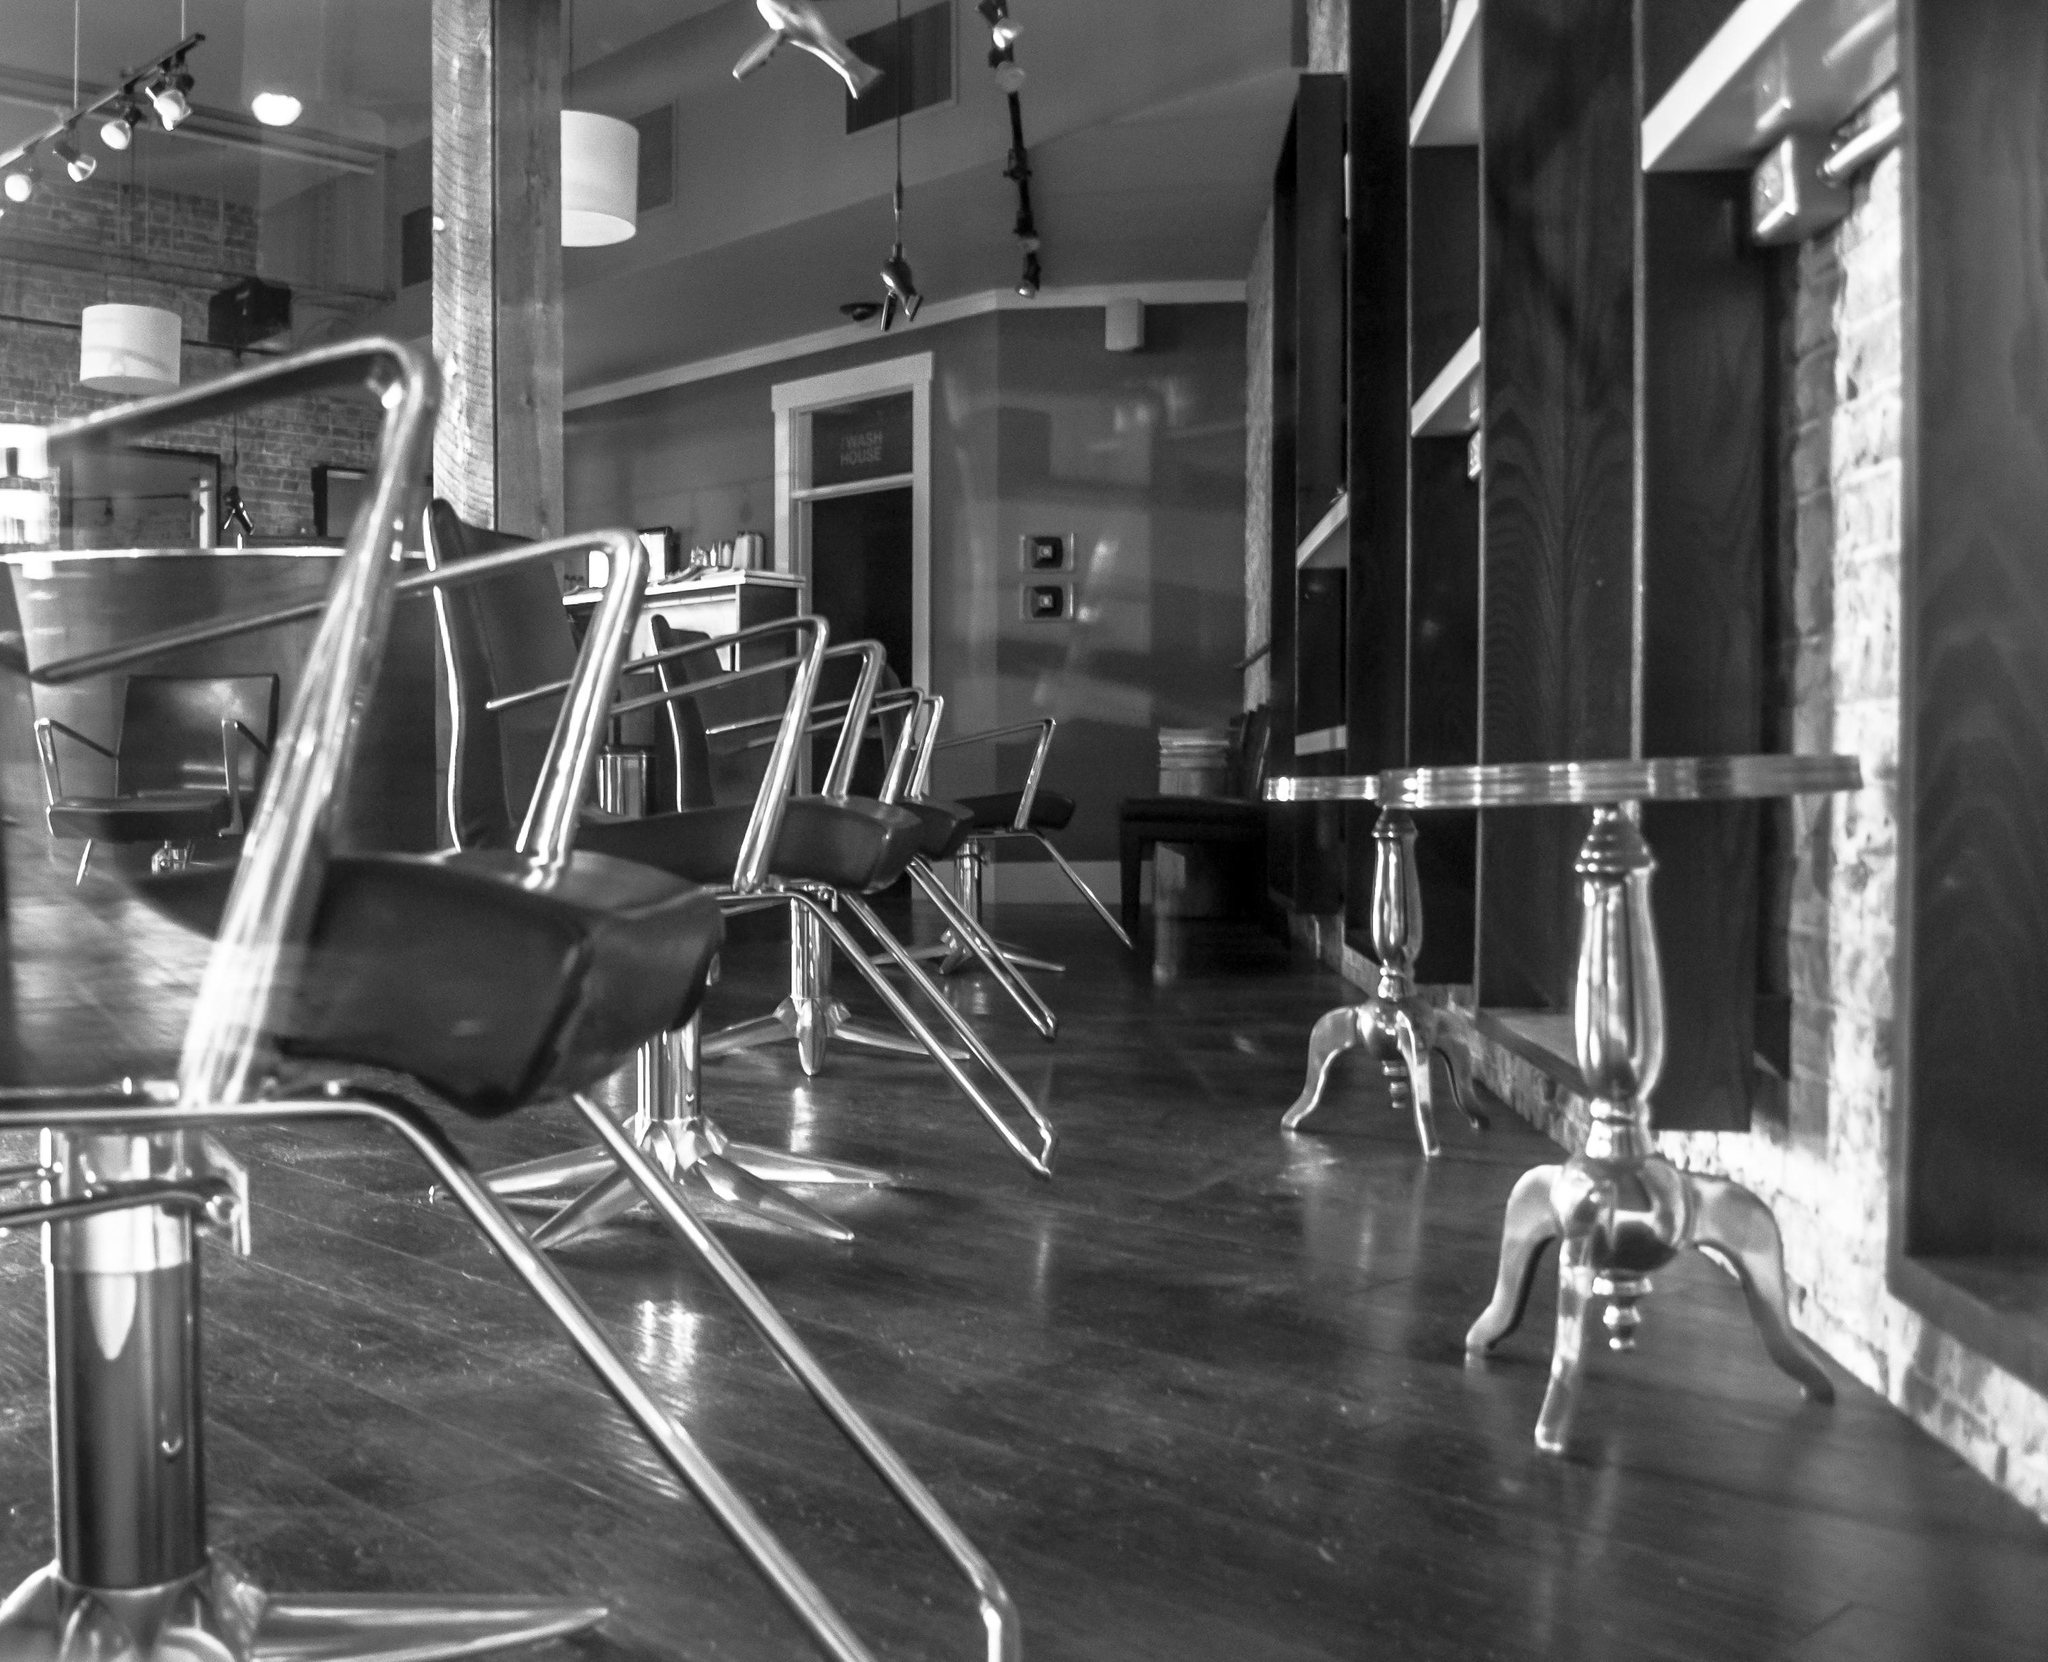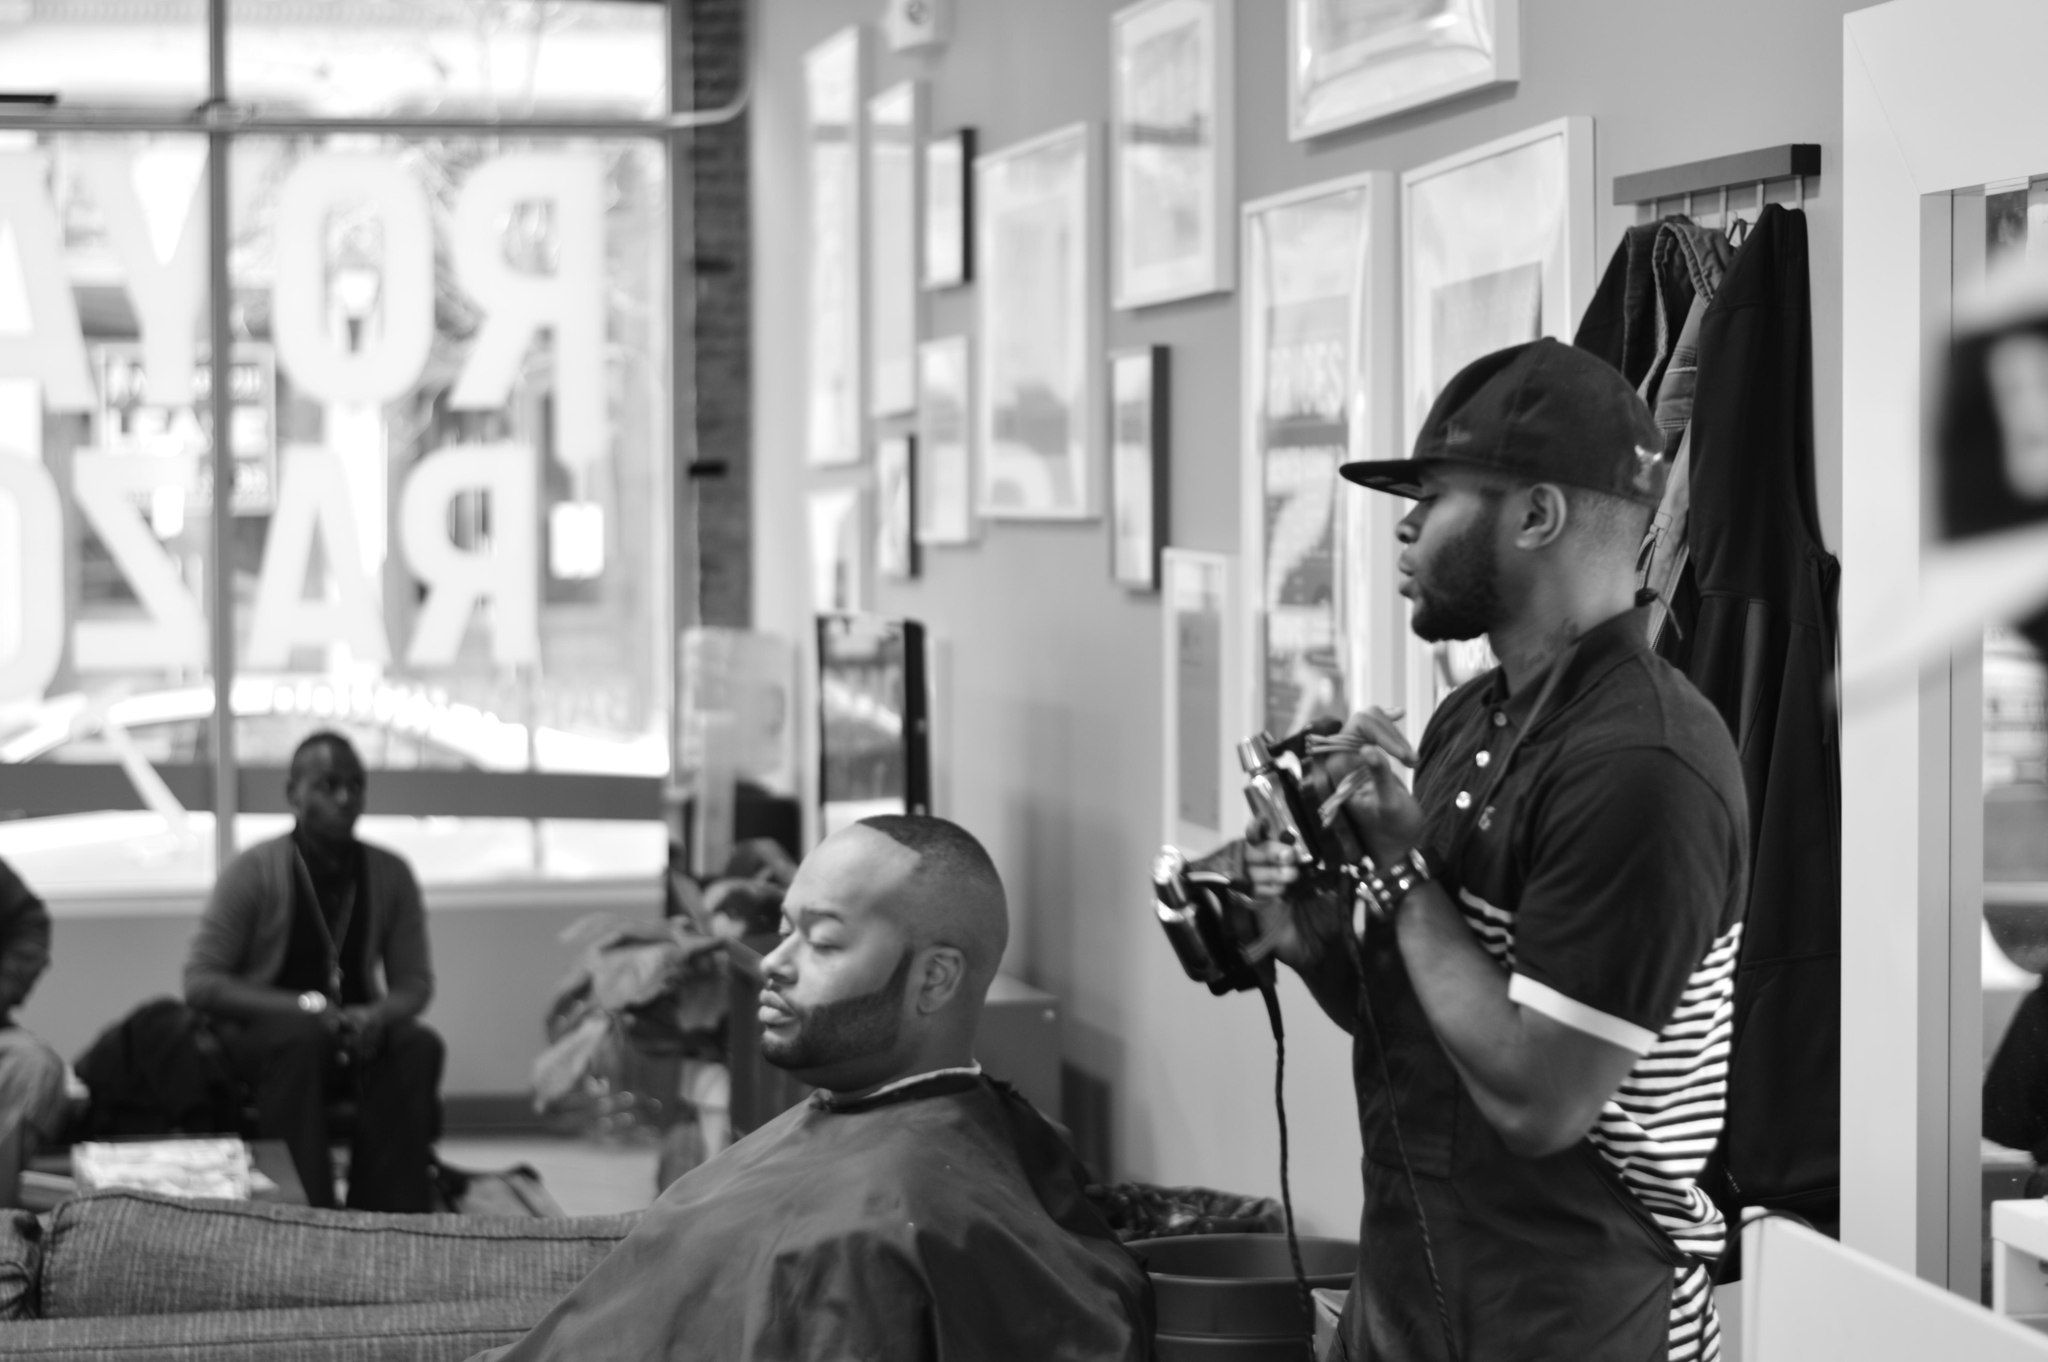The first image is the image on the left, the second image is the image on the right. Analyze the images presented: Is the assertion "A barbershop image shows a man sitting in a barber chair with other people in the shop, and large windows in the background." valid? Answer yes or no. Yes. The first image is the image on the left, the second image is the image on the right. Evaluate the accuracy of this statement regarding the images: "An image shows a display of barber tools, including scissors.". Is it true? Answer yes or no. No. 